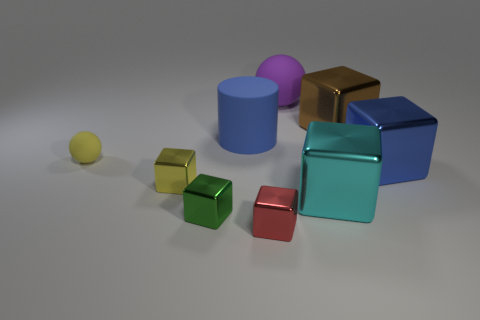How does the arrangement of objects affect the perception of size? The progressive arrangement of objects from smallest to largest leads to a perception of increasing size, which gives a sense of scale and may also create a visually pleasing gradient effect. 